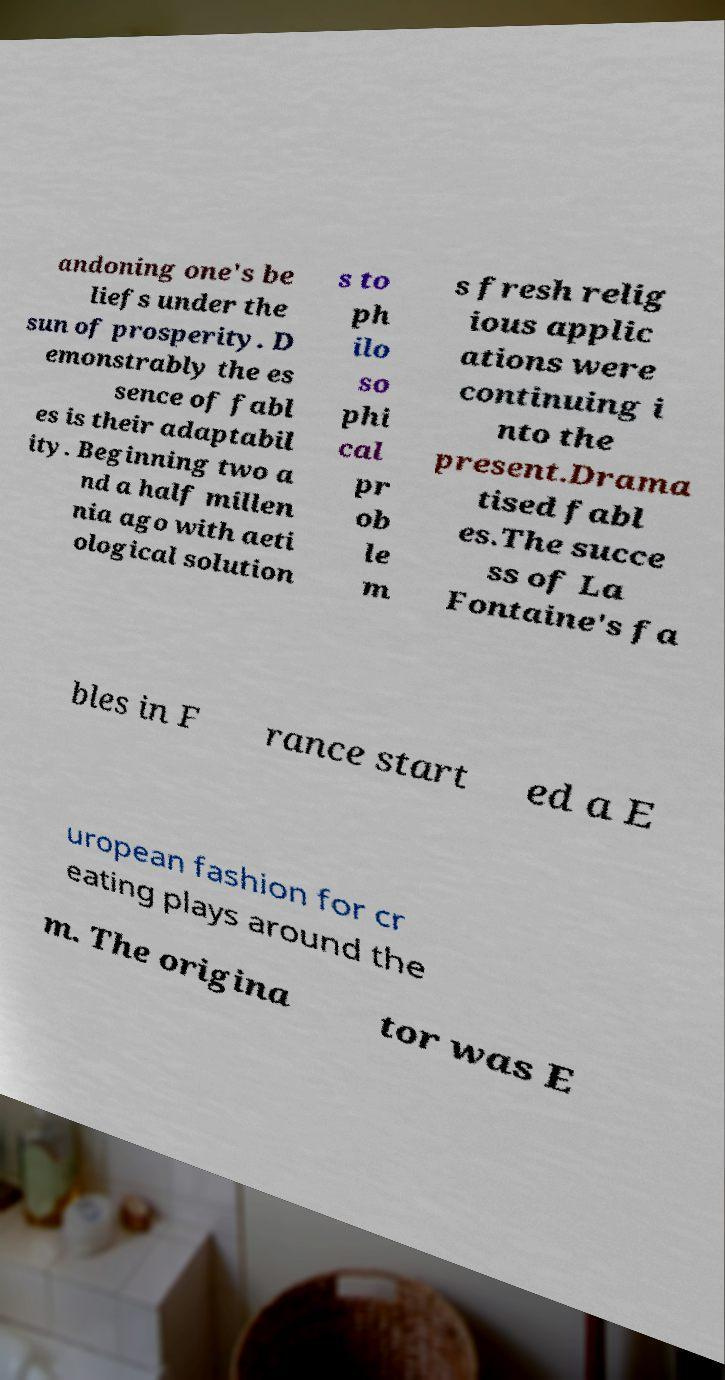There's text embedded in this image that I need extracted. Can you transcribe it verbatim? andoning one's be liefs under the sun of prosperity. D emonstrably the es sence of fabl es is their adaptabil ity. Beginning two a nd a half millen nia ago with aeti ological solution s to ph ilo so phi cal pr ob le m s fresh relig ious applic ations were continuing i nto the present.Drama tised fabl es.The succe ss of La Fontaine's fa bles in F rance start ed a E uropean fashion for cr eating plays around the m. The origina tor was E 